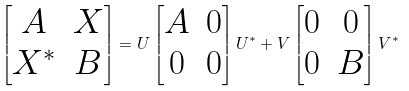<formula> <loc_0><loc_0><loc_500><loc_500>\begin{bmatrix} A & X \\ X ^ { * } & B \end{bmatrix} = U \begin{bmatrix} A & 0 \\ 0 & 0 \end{bmatrix} U ^ { * } + V \begin{bmatrix} 0 & 0 \\ 0 & B \end{bmatrix} V ^ { * }</formula> 